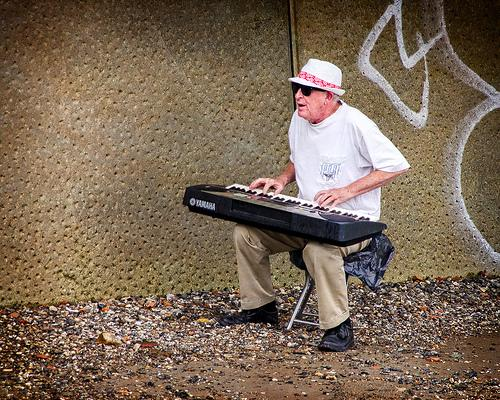What detail can be seen on the wall behind the man, and how would you describe the wall's color? There are multiple dents in the brown wall behind the man. Which instrument is visible in the image and who is playing it? A keyboard is visible, and an elderly man is playing it. If you were to create an advertisement for this image, what product would you focus on and how would you describe it? I would focus on the keyboard as the product, describing it as a versatile and elegantly designed instrument perfect for skilled keyboard players like the elderly man in the image. What action is the main subject performing in this image? The man is playing the keyboard. What is the man in the image wearing on his head and face? The man is wearing a white hat and black sunglasses. Choose and describe one element from the man's apparel and one element from his surroundings. The man is wearing a white T-shirt, and there are rocks and glass on the ground. Identify two features of the man's outfit in the image. The man is wearing a white T-shirt and black pants. 